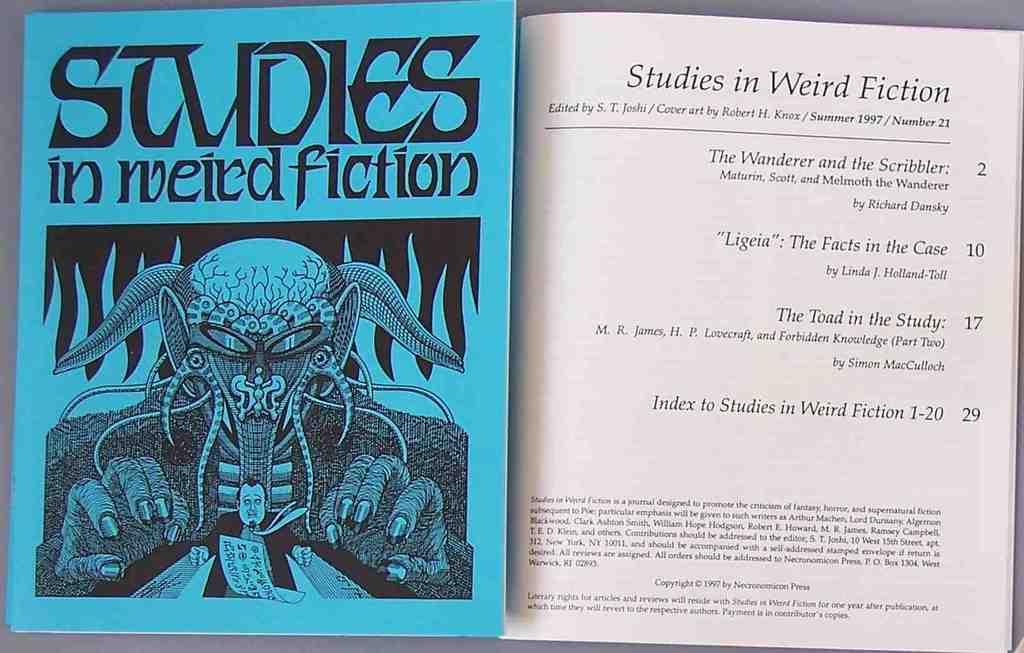What is the title of this book?
Ensure brevity in your answer.  Studies in weird fiction. 